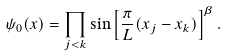<formula> <loc_0><loc_0><loc_500><loc_500>\psi _ { 0 } ( x ) = \prod _ { j < k } \sin \left [ \frac { \pi } { L } ( x _ { j } - x _ { k } ) \right ] ^ { \beta } .</formula> 